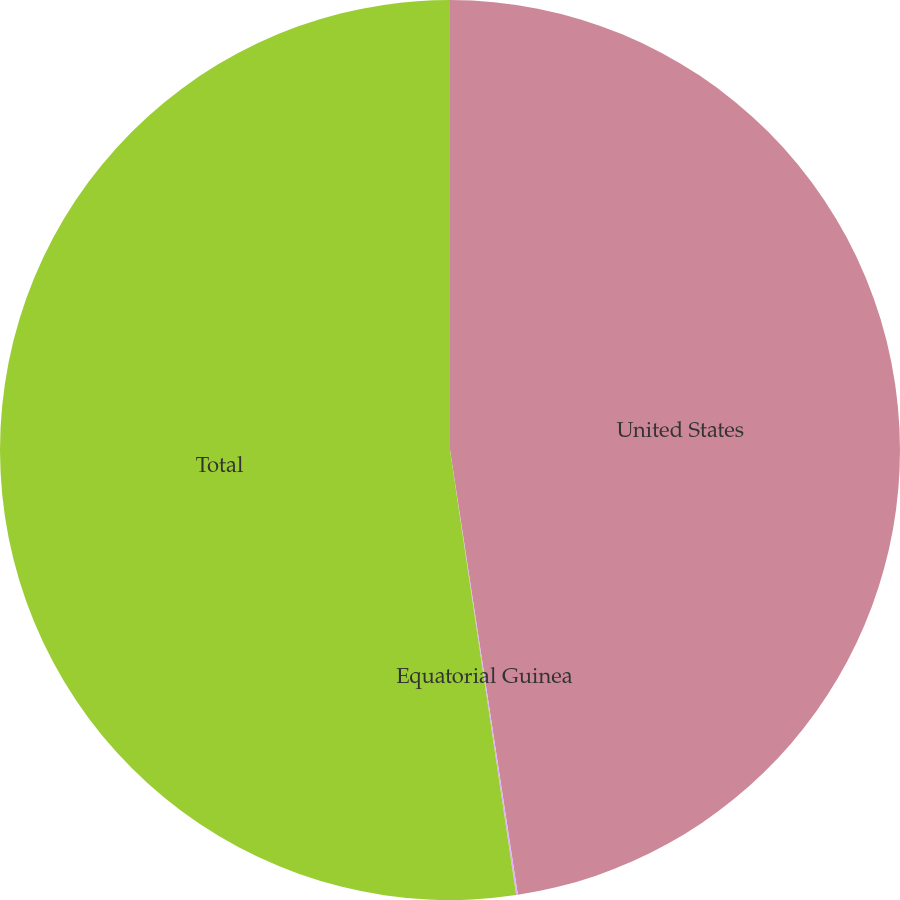<chart> <loc_0><loc_0><loc_500><loc_500><pie_chart><fcel>United States<fcel>Equatorial Guinea<fcel>Total<nl><fcel>47.59%<fcel>0.06%<fcel>52.35%<nl></chart> 